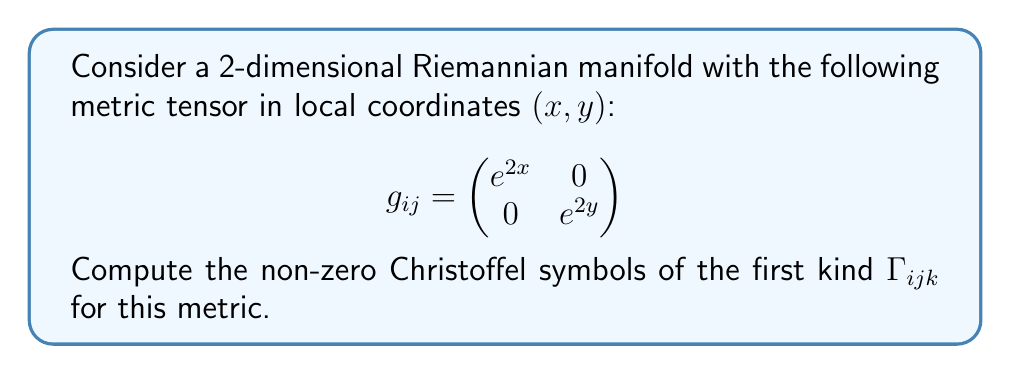Solve this math problem. To compute the Christoffel symbols of the first kind, we use the formula:

$$\Gamma_{ijk} = \frac{1}{2}\left(\frac{\partial g_{ij}}{\partial x^k} + \frac{\partial g_{ik}}{\partial x^j} - \frac{\partial g_{jk}}{\partial x^i}\right)$$

where $x^1 = x$ and $x^2 = y$.

Step 1: Calculate the partial derivatives of the metric components.
$\frac{\partial g_{11}}{\partial x} = 2e^{2x}$
$\frac{\partial g_{11}}{\partial y} = 0$
$\frac{\partial g_{22}}{\partial x} = 0$
$\frac{\partial g_{22}}{\partial y} = 2e^{2y}$
All other partial derivatives are zero.

Step 2: Compute the non-zero Christoffel symbols.

For $\Gamma_{111}$:
$$\Gamma_{111} = \frac{1}{2}\left(\frac{\partial g_{11}}{\partial x} + \frac{\partial g_{11}}{\partial x} - \frac{\partial g_{11}}{\partial x}\right) = \frac{1}{2}(2e^{2x} + 2e^{2x} - 2e^{2x}) = e^{2x}$$

For $\Gamma_{221}$:
$$\Gamma_{221} = \frac{1}{2}\left(\frac{\partial g_{22}}{\partial x} + \frac{\partial g_{21}}{\partial y} - \frac{\partial g_{12}}{\partial y}\right) = \frac{1}{2}(0 + 0 - 0) = 0$$

For $\Gamma_{122}$:
$$\Gamma_{122} = \frac{1}{2}\left(\frac{\partial g_{12}}{\partial y} + \frac{\partial g_{12}}{\partial y} - \frac{\partial g_{22}}{\partial x}\right) = \frac{1}{2}(0 + 0 - 0) = 0$$

For $\Gamma_{222}$:
$$\Gamma_{222} = \frac{1}{2}\left(\frac{\partial g_{22}}{\partial y} + \frac{\partial g_{22}}{\partial y} - \frac{\partial g_{22}}{\partial y}\right) = \frac{1}{2}(2e^{2y} + 2e^{2y} - 2e^{2y}) = e^{2y}$$

All other Christoffel symbols of the first kind are zero due to the diagonal nature of the metric tensor.
Answer: $\Gamma_{111} = e^{2x}$, $\Gamma_{222} = e^{2y}$, all others zero. 